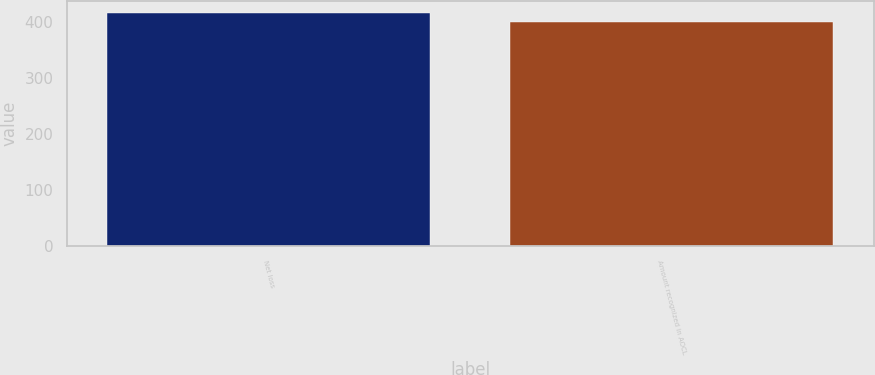Convert chart. <chart><loc_0><loc_0><loc_500><loc_500><bar_chart><fcel>Net loss<fcel>Amount recognized in AOCL<nl><fcel>417<fcel>400.3<nl></chart> 